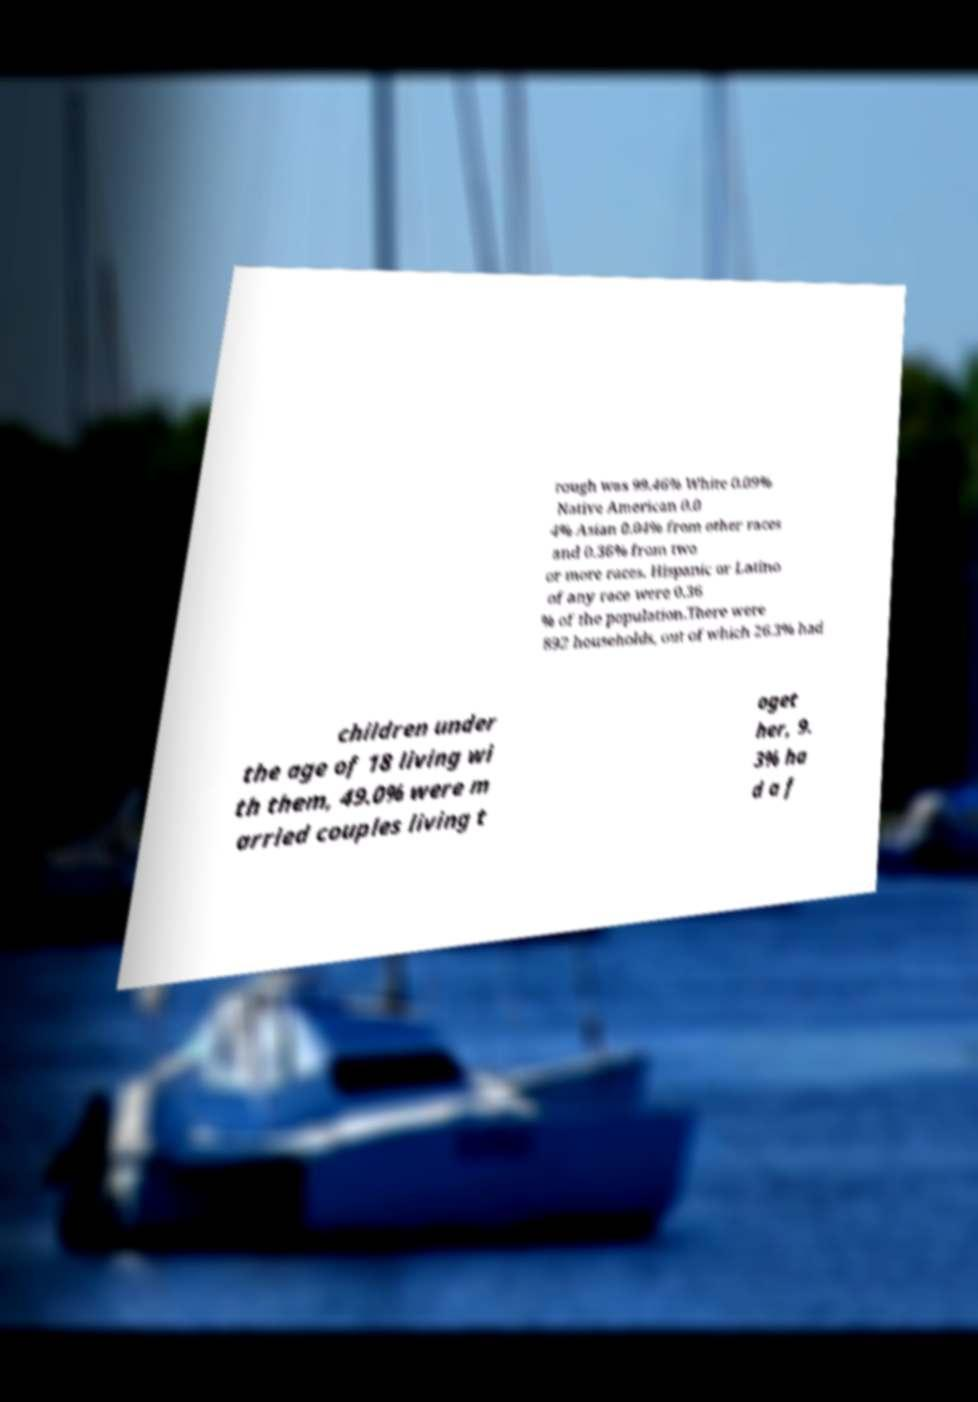For documentation purposes, I need the text within this image transcribed. Could you provide that? rough was 99.46% White 0.09% Native American 0.0 4% Asian 0.04% from other races and 0.36% from two or more races. Hispanic or Latino of any race were 0.36 % of the population.There were 892 households, out of which 26.3% had children under the age of 18 living wi th them, 49.0% were m arried couples living t oget her, 9. 3% ha d a f 